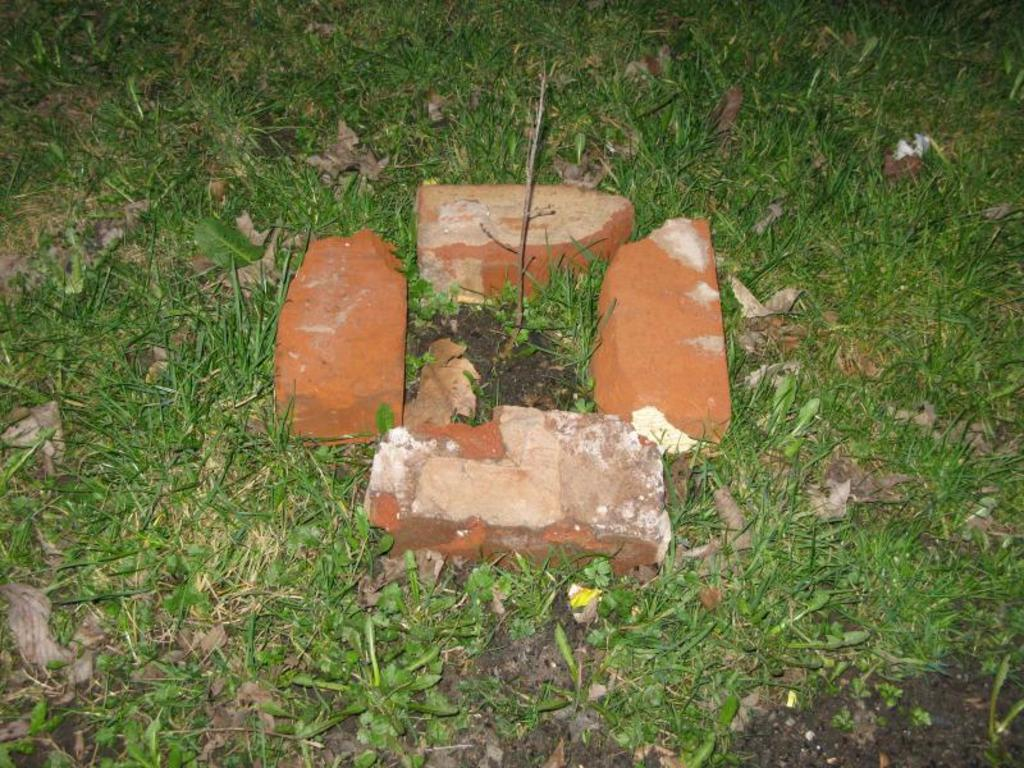What is the main subject in the center of the image? There is a plant in the center of the image. What material is used to surround the plant? There are bricks surrounding the plant. What type of vegetation is present on the surface at the bottom of the image? There is grass on the surface at the bottom of the image. How many snails can be seen crawling on the plant in the image? There are no snails present in the image; it only features a plant surrounded by bricks and grass on the surface. 